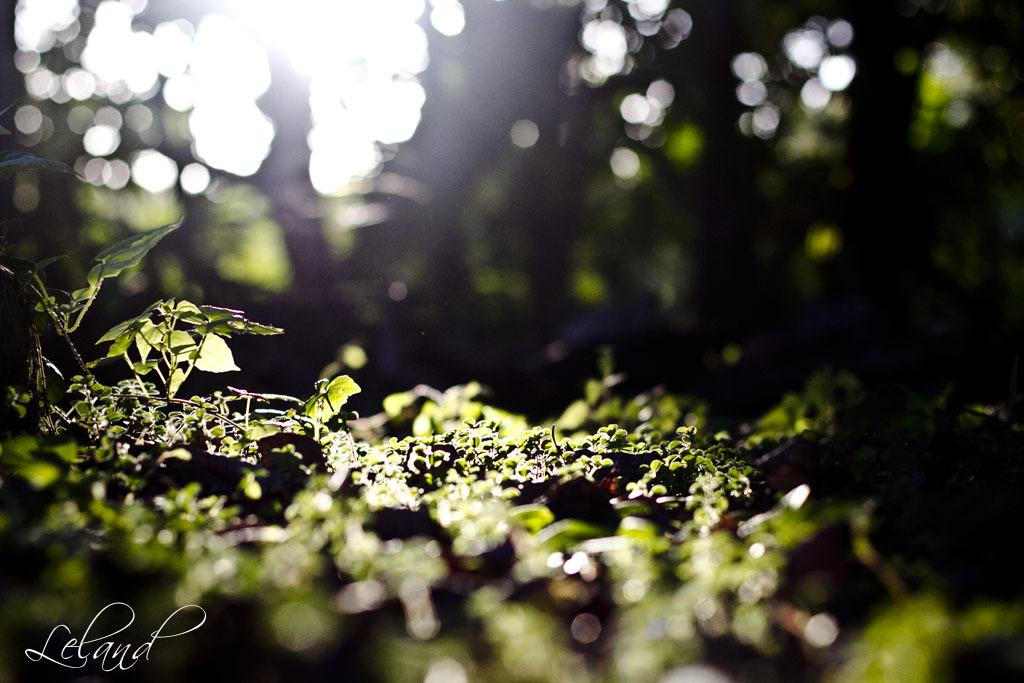What is the main subject of the image? The main subject of the image is a place. What can be found within this place? The place contains plants. What type of office furniture can be seen in the image? There is no mention of an office or any furniture in the image, as it only contains a place with plants. 